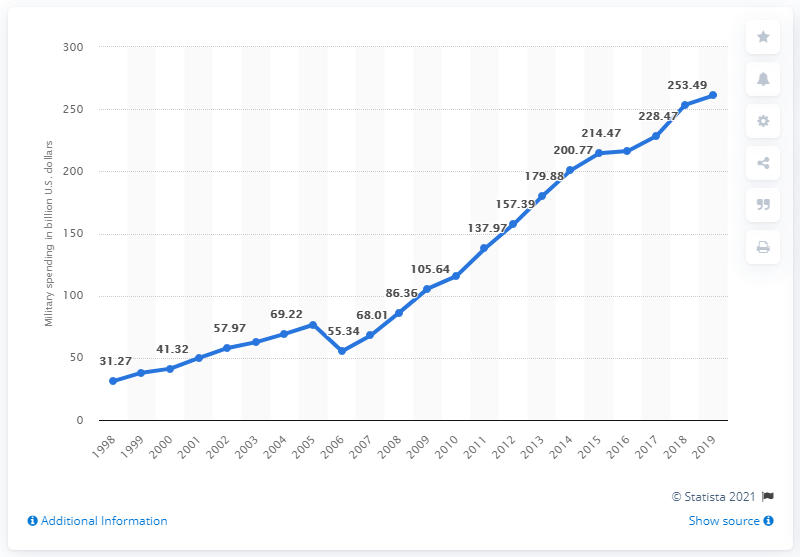Identify some key points in this picture. According to the latest data, China's military expenditure in 2019 was approximately 261.08 billion US dollars. 